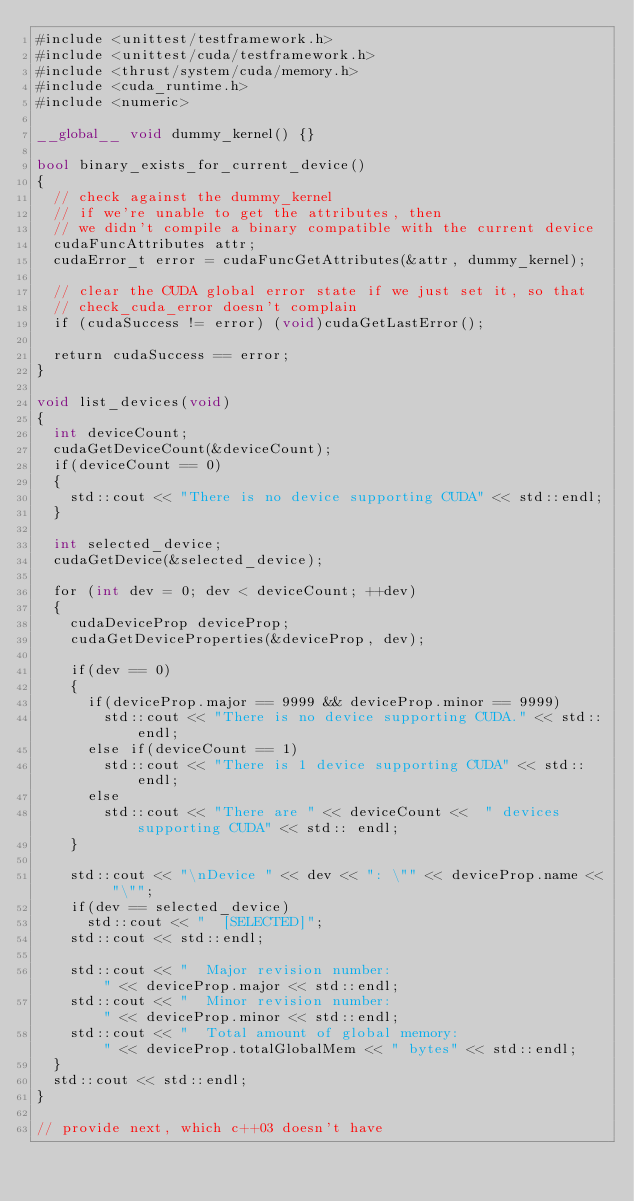Convert code to text. <code><loc_0><loc_0><loc_500><loc_500><_Cuda_>#include <unittest/testframework.h>
#include <unittest/cuda/testframework.h>
#include <thrust/system/cuda/memory.h>
#include <cuda_runtime.h>
#include <numeric>

__global__ void dummy_kernel() {}

bool binary_exists_for_current_device()
{
  // check against the dummy_kernel
  // if we're unable to get the attributes, then
  // we didn't compile a binary compatible with the current device
  cudaFuncAttributes attr;
  cudaError_t error = cudaFuncGetAttributes(&attr, dummy_kernel);

  // clear the CUDA global error state if we just set it, so that
  // check_cuda_error doesn't complain
  if (cudaSuccess != error) (void)cudaGetLastError();

  return cudaSuccess == error;
}

void list_devices(void)
{
  int deviceCount;
  cudaGetDeviceCount(&deviceCount);
  if(deviceCount == 0)
  {
    std::cout << "There is no device supporting CUDA" << std::endl;
  }
  
  int selected_device;
  cudaGetDevice(&selected_device);
  
  for (int dev = 0; dev < deviceCount; ++dev)
  {
    cudaDeviceProp deviceProp;
    cudaGetDeviceProperties(&deviceProp, dev);
    
    if(dev == 0)
    {
      if(deviceProp.major == 9999 && deviceProp.minor == 9999)
        std::cout << "There is no device supporting CUDA." << std::endl;
      else if(deviceCount == 1)
        std::cout << "There is 1 device supporting CUDA" << std:: endl;
      else
        std::cout << "There are " << deviceCount <<  " devices supporting CUDA" << std:: endl;
    }
    
    std::cout << "\nDevice " << dev << ": \"" << deviceProp.name << "\"";
    if(dev == selected_device)
      std::cout << "  [SELECTED]";
    std::cout << std::endl;
    
    std::cout << "  Major revision number:                         " << deviceProp.major << std::endl;
    std::cout << "  Minor revision number:                         " << deviceProp.minor << std::endl;
    std::cout << "  Total amount of global memory:                 " << deviceProp.totalGlobalMem << " bytes" << std::endl;
  }
  std::cout << std::endl;
}

// provide next, which c++03 doesn't have</code> 